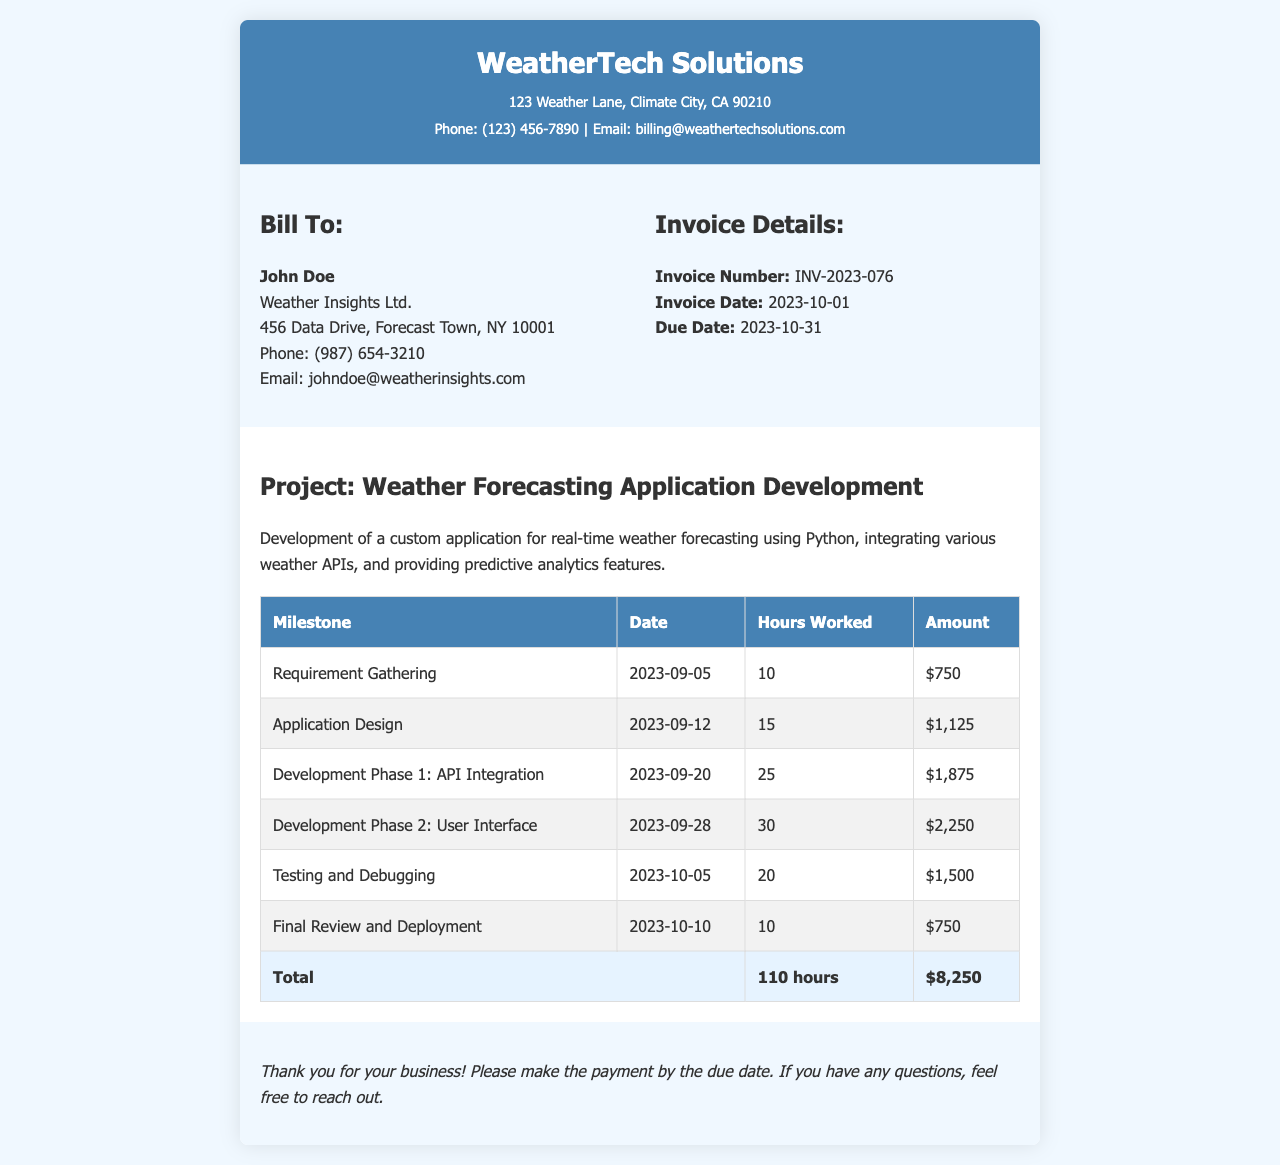What is the invoice number? The invoice number is listed under the invoice details section of the document.
Answer: INV-2023-076 When was the invoice issued? The invoice date is clearly stated in the invoice details section.
Answer: 2023-10-01 What is the total amount due? The total amount is listed in the total row of the milestones table.
Answer: $8,250 How many hours were worked in the Development Phase 1? The hours worked for Development Phase 1 are specified in the respective row of the milestones table.
Answer: 25 Which milestone had the highest hours worked? This requires comparing the hours worked across all milestones. The milestone with the highest hours is noted.
Answer: Development Phase 2: User Interface What is the due date for the invoice? The due date is mentioned in the invoice details section.
Answer: 2023-10-31 Who is the client for this invoice? The client information is provided in the "Bill To" section of the document.
Answer: John Doe What is the total number of milestones listed? To find this, count the rows in the milestones table which represent the milestones.
Answer: 6 What is the name of the project? The project name is specified in the project details section.
Answer: Weather Forecasting Application Development 